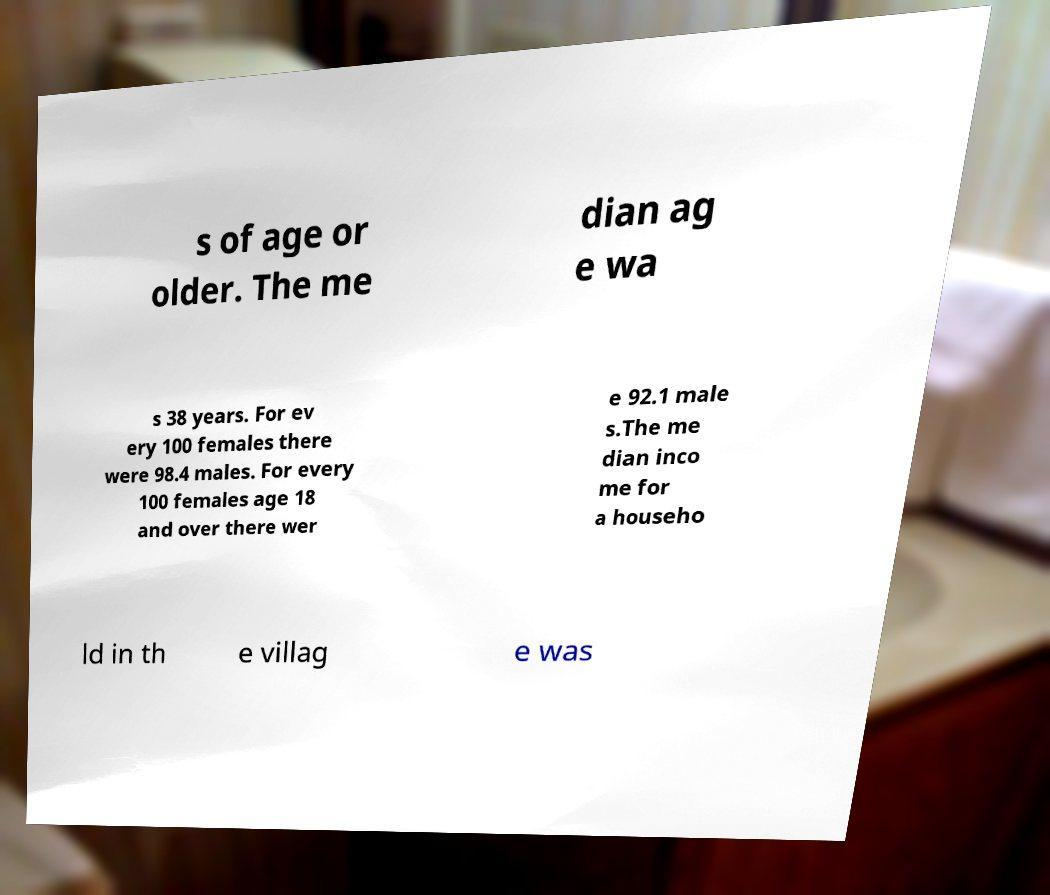I need the written content from this picture converted into text. Can you do that? s of age or older. The me dian ag e wa s 38 years. For ev ery 100 females there were 98.4 males. For every 100 females age 18 and over there wer e 92.1 male s.The me dian inco me for a househo ld in th e villag e was 